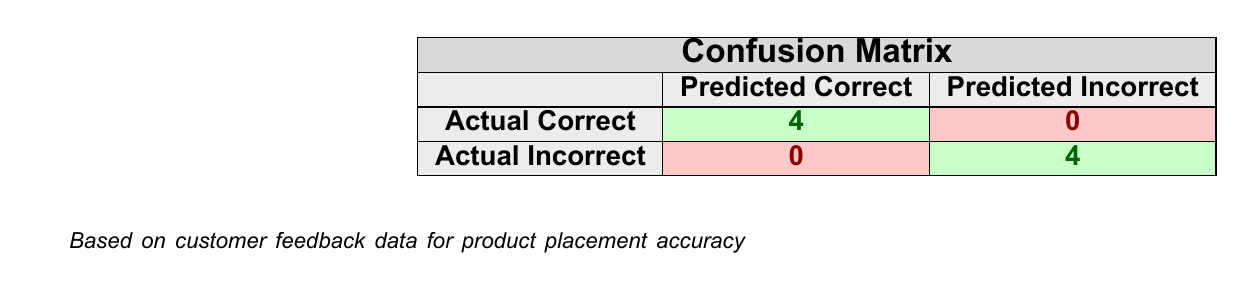What is the total number of correctly placed products? The table shows that there were 4 instances where the product was placed correctly according to customer feedback, as indicated in the "Actual Correct" row under "Predicted Correct".
Answer: 4 How many products were placed incorrectly? The table indicates that there are 4 instances listed under the "Actual Incorrect" row in the "Predicted Incorrect" column, which signifies that none of the instances were placed incorrectly according to the feedback given.
Answer: 0 Is it true that all the products were marked as placed incorrectly? By reviewing the data, the table indicates that under the "Actual Incorrect" row in the "Predicted Correct" category, there are 0 products, which means that not all products were incorrectly placed.
Answer: No What is the ratio of correctly placed products to incorrectly placed products? The number of correctly placed products is 4, and incorrectly placed products is 0. Therefore, the ratio is 4:0 or undefined, since dividing by zero is not possible, but it demonstrates that all products either were correctly placed or were not placed at all.
Answer: Undefined If a product is correctly placed, what can be inferred about customer satisfaction based on the feedback? Since there are 4 correctly placed products, we can infer that the feedback received for these products was positive, as customers mentioned finding the products in expected locations, which suggests satisfaction with placement.
Answer: Positive inference What would be the effect on overall customer experience if all placements were correct? Given that currently 4 out of 8 ratings are positive, if all placements were correct, it is reasonable to assume that customer experience would improve, leading to potentially higher satisfaction, repurchases, and customer loyalty due to easy accessibility.
Answer: Improved experience 